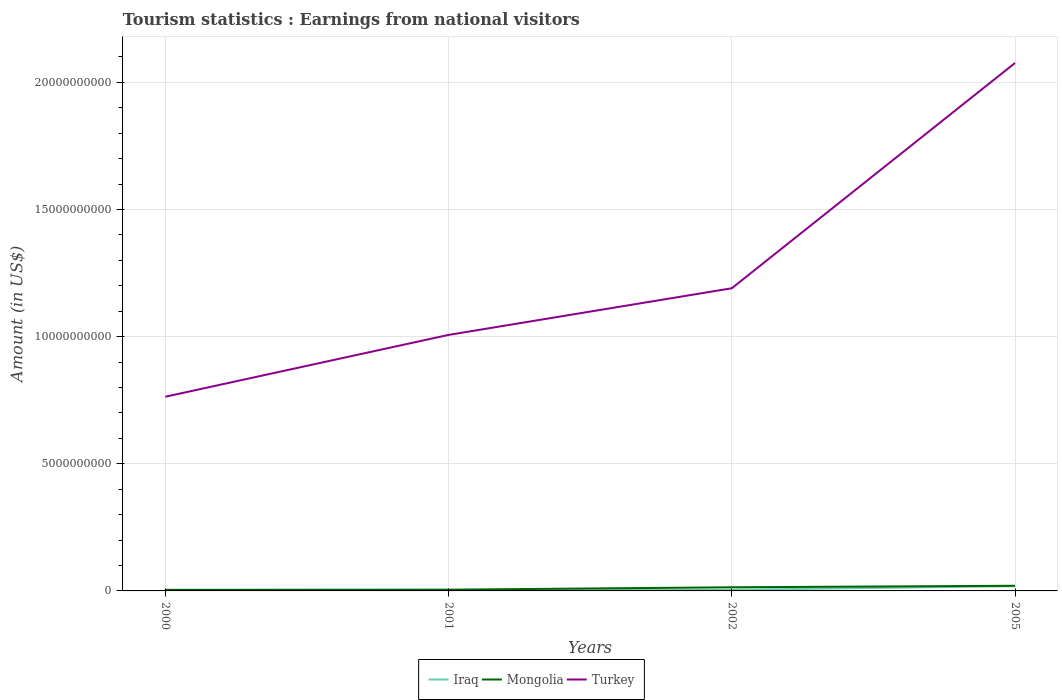Across all years, what is the maximum earnings from national visitors in Turkey?
Give a very brief answer. 7.64e+09. In which year was the earnings from national visitors in Iraq maximum?
Give a very brief answer. 2000. What is the total earnings from national visitors in Iraq in the graph?
Provide a succinct answer. -3.00e+07. What is the difference between the highest and the second highest earnings from national visitors in Turkey?
Provide a succinct answer. 1.31e+1. Are the values on the major ticks of Y-axis written in scientific E-notation?
Offer a terse response. No. Does the graph contain any zero values?
Give a very brief answer. No. Does the graph contain grids?
Ensure brevity in your answer.  Yes. Where does the legend appear in the graph?
Provide a succinct answer. Bottom center. How many legend labels are there?
Offer a terse response. 3. How are the legend labels stacked?
Offer a terse response. Horizontal. What is the title of the graph?
Offer a very short reply. Tourism statistics : Earnings from national visitors. Does "Bermuda" appear as one of the legend labels in the graph?
Make the answer very short. No. What is the label or title of the Y-axis?
Ensure brevity in your answer.  Amount (in US$). What is the Amount (in US$) of Iraq in 2000?
Your response must be concise. 2.00e+06. What is the Amount (in US$) of Mongolia in 2000?
Offer a terse response. 4.30e+07. What is the Amount (in US$) in Turkey in 2000?
Offer a very short reply. 7.64e+09. What is the Amount (in US$) of Iraq in 2001?
Provide a short and direct response. 1.50e+07. What is the Amount (in US$) in Mongolia in 2001?
Ensure brevity in your answer.  4.90e+07. What is the Amount (in US$) of Turkey in 2001?
Ensure brevity in your answer.  1.01e+1. What is the Amount (in US$) of Iraq in 2002?
Offer a terse response. 4.50e+07. What is the Amount (in US$) in Mongolia in 2002?
Your response must be concise. 1.43e+08. What is the Amount (in US$) of Turkey in 2002?
Provide a short and direct response. 1.19e+1. What is the Amount (in US$) in Iraq in 2005?
Give a very brief answer. 1.86e+08. What is the Amount (in US$) of Mongolia in 2005?
Your response must be concise. 2.03e+08. What is the Amount (in US$) of Turkey in 2005?
Offer a very short reply. 2.08e+1. Across all years, what is the maximum Amount (in US$) of Iraq?
Offer a very short reply. 1.86e+08. Across all years, what is the maximum Amount (in US$) of Mongolia?
Your answer should be very brief. 2.03e+08. Across all years, what is the maximum Amount (in US$) in Turkey?
Ensure brevity in your answer.  2.08e+1. Across all years, what is the minimum Amount (in US$) of Mongolia?
Give a very brief answer. 4.30e+07. Across all years, what is the minimum Amount (in US$) in Turkey?
Your response must be concise. 7.64e+09. What is the total Amount (in US$) in Iraq in the graph?
Your answer should be compact. 2.48e+08. What is the total Amount (in US$) in Mongolia in the graph?
Make the answer very short. 4.38e+08. What is the total Amount (in US$) in Turkey in the graph?
Provide a short and direct response. 5.04e+1. What is the difference between the Amount (in US$) in Iraq in 2000 and that in 2001?
Make the answer very short. -1.30e+07. What is the difference between the Amount (in US$) of Mongolia in 2000 and that in 2001?
Your answer should be compact. -6.00e+06. What is the difference between the Amount (in US$) of Turkey in 2000 and that in 2001?
Keep it short and to the point. -2.43e+09. What is the difference between the Amount (in US$) of Iraq in 2000 and that in 2002?
Provide a succinct answer. -4.30e+07. What is the difference between the Amount (in US$) in Mongolia in 2000 and that in 2002?
Give a very brief answer. -1.00e+08. What is the difference between the Amount (in US$) of Turkey in 2000 and that in 2002?
Your answer should be very brief. -4.26e+09. What is the difference between the Amount (in US$) in Iraq in 2000 and that in 2005?
Offer a very short reply. -1.84e+08. What is the difference between the Amount (in US$) in Mongolia in 2000 and that in 2005?
Ensure brevity in your answer.  -1.60e+08. What is the difference between the Amount (in US$) of Turkey in 2000 and that in 2005?
Provide a short and direct response. -1.31e+1. What is the difference between the Amount (in US$) in Iraq in 2001 and that in 2002?
Provide a succinct answer. -3.00e+07. What is the difference between the Amount (in US$) of Mongolia in 2001 and that in 2002?
Offer a very short reply. -9.40e+07. What is the difference between the Amount (in US$) of Turkey in 2001 and that in 2002?
Provide a succinct answer. -1.83e+09. What is the difference between the Amount (in US$) of Iraq in 2001 and that in 2005?
Your answer should be very brief. -1.71e+08. What is the difference between the Amount (in US$) of Mongolia in 2001 and that in 2005?
Provide a succinct answer. -1.54e+08. What is the difference between the Amount (in US$) of Turkey in 2001 and that in 2005?
Ensure brevity in your answer.  -1.07e+1. What is the difference between the Amount (in US$) in Iraq in 2002 and that in 2005?
Your response must be concise. -1.41e+08. What is the difference between the Amount (in US$) in Mongolia in 2002 and that in 2005?
Keep it short and to the point. -6.00e+07. What is the difference between the Amount (in US$) of Turkey in 2002 and that in 2005?
Provide a succinct answer. -8.86e+09. What is the difference between the Amount (in US$) of Iraq in 2000 and the Amount (in US$) of Mongolia in 2001?
Keep it short and to the point. -4.70e+07. What is the difference between the Amount (in US$) of Iraq in 2000 and the Amount (in US$) of Turkey in 2001?
Your answer should be compact. -1.01e+1. What is the difference between the Amount (in US$) in Mongolia in 2000 and the Amount (in US$) in Turkey in 2001?
Your answer should be compact. -1.00e+1. What is the difference between the Amount (in US$) in Iraq in 2000 and the Amount (in US$) in Mongolia in 2002?
Keep it short and to the point. -1.41e+08. What is the difference between the Amount (in US$) of Iraq in 2000 and the Amount (in US$) of Turkey in 2002?
Make the answer very short. -1.19e+1. What is the difference between the Amount (in US$) in Mongolia in 2000 and the Amount (in US$) in Turkey in 2002?
Give a very brief answer. -1.19e+1. What is the difference between the Amount (in US$) in Iraq in 2000 and the Amount (in US$) in Mongolia in 2005?
Offer a terse response. -2.01e+08. What is the difference between the Amount (in US$) in Iraq in 2000 and the Amount (in US$) in Turkey in 2005?
Provide a succinct answer. -2.08e+1. What is the difference between the Amount (in US$) of Mongolia in 2000 and the Amount (in US$) of Turkey in 2005?
Your answer should be compact. -2.07e+1. What is the difference between the Amount (in US$) of Iraq in 2001 and the Amount (in US$) of Mongolia in 2002?
Your response must be concise. -1.28e+08. What is the difference between the Amount (in US$) of Iraq in 2001 and the Amount (in US$) of Turkey in 2002?
Make the answer very short. -1.19e+1. What is the difference between the Amount (in US$) in Mongolia in 2001 and the Amount (in US$) in Turkey in 2002?
Provide a short and direct response. -1.19e+1. What is the difference between the Amount (in US$) in Iraq in 2001 and the Amount (in US$) in Mongolia in 2005?
Offer a terse response. -1.88e+08. What is the difference between the Amount (in US$) of Iraq in 2001 and the Amount (in US$) of Turkey in 2005?
Offer a terse response. -2.07e+1. What is the difference between the Amount (in US$) in Mongolia in 2001 and the Amount (in US$) in Turkey in 2005?
Your response must be concise. -2.07e+1. What is the difference between the Amount (in US$) of Iraq in 2002 and the Amount (in US$) of Mongolia in 2005?
Make the answer very short. -1.58e+08. What is the difference between the Amount (in US$) in Iraq in 2002 and the Amount (in US$) in Turkey in 2005?
Offer a very short reply. -2.07e+1. What is the difference between the Amount (in US$) of Mongolia in 2002 and the Amount (in US$) of Turkey in 2005?
Provide a succinct answer. -2.06e+1. What is the average Amount (in US$) of Iraq per year?
Your answer should be very brief. 6.20e+07. What is the average Amount (in US$) of Mongolia per year?
Offer a very short reply. 1.10e+08. What is the average Amount (in US$) of Turkey per year?
Your answer should be very brief. 1.26e+1. In the year 2000, what is the difference between the Amount (in US$) in Iraq and Amount (in US$) in Mongolia?
Your answer should be compact. -4.10e+07. In the year 2000, what is the difference between the Amount (in US$) in Iraq and Amount (in US$) in Turkey?
Offer a very short reply. -7.63e+09. In the year 2000, what is the difference between the Amount (in US$) of Mongolia and Amount (in US$) of Turkey?
Provide a succinct answer. -7.59e+09. In the year 2001, what is the difference between the Amount (in US$) of Iraq and Amount (in US$) of Mongolia?
Offer a very short reply. -3.40e+07. In the year 2001, what is the difference between the Amount (in US$) in Iraq and Amount (in US$) in Turkey?
Provide a succinct answer. -1.01e+1. In the year 2001, what is the difference between the Amount (in US$) in Mongolia and Amount (in US$) in Turkey?
Provide a succinct answer. -1.00e+1. In the year 2002, what is the difference between the Amount (in US$) of Iraq and Amount (in US$) of Mongolia?
Provide a succinct answer. -9.80e+07. In the year 2002, what is the difference between the Amount (in US$) of Iraq and Amount (in US$) of Turkey?
Your answer should be very brief. -1.19e+1. In the year 2002, what is the difference between the Amount (in US$) in Mongolia and Amount (in US$) in Turkey?
Your answer should be compact. -1.18e+1. In the year 2005, what is the difference between the Amount (in US$) in Iraq and Amount (in US$) in Mongolia?
Your response must be concise. -1.70e+07. In the year 2005, what is the difference between the Amount (in US$) of Iraq and Amount (in US$) of Turkey?
Your answer should be very brief. -2.06e+1. In the year 2005, what is the difference between the Amount (in US$) of Mongolia and Amount (in US$) of Turkey?
Your answer should be very brief. -2.06e+1. What is the ratio of the Amount (in US$) of Iraq in 2000 to that in 2001?
Ensure brevity in your answer.  0.13. What is the ratio of the Amount (in US$) of Mongolia in 2000 to that in 2001?
Your answer should be very brief. 0.88. What is the ratio of the Amount (in US$) of Turkey in 2000 to that in 2001?
Your answer should be compact. 0.76. What is the ratio of the Amount (in US$) in Iraq in 2000 to that in 2002?
Ensure brevity in your answer.  0.04. What is the ratio of the Amount (in US$) of Mongolia in 2000 to that in 2002?
Your answer should be very brief. 0.3. What is the ratio of the Amount (in US$) in Turkey in 2000 to that in 2002?
Give a very brief answer. 0.64. What is the ratio of the Amount (in US$) in Iraq in 2000 to that in 2005?
Give a very brief answer. 0.01. What is the ratio of the Amount (in US$) in Mongolia in 2000 to that in 2005?
Offer a very short reply. 0.21. What is the ratio of the Amount (in US$) in Turkey in 2000 to that in 2005?
Provide a succinct answer. 0.37. What is the ratio of the Amount (in US$) of Iraq in 2001 to that in 2002?
Your answer should be compact. 0.33. What is the ratio of the Amount (in US$) in Mongolia in 2001 to that in 2002?
Make the answer very short. 0.34. What is the ratio of the Amount (in US$) in Turkey in 2001 to that in 2002?
Offer a very short reply. 0.85. What is the ratio of the Amount (in US$) in Iraq in 2001 to that in 2005?
Provide a short and direct response. 0.08. What is the ratio of the Amount (in US$) in Mongolia in 2001 to that in 2005?
Give a very brief answer. 0.24. What is the ratio of the Amount (in US$) of Turkey in 2001 to that in 2005?
Ensure brevity in your answer.  0.48. What is the ratio of the Amount (in US$) in Iraq in 2002 to that in 2005?
Offer a very short reply. 0.24. What is the ratio of the Amount (in US$) of Mongolia in 2002 to that in 2005?
Make the answer very short. 0.7. What is the ratio of the Amount (in US$) of Turkey in 2002 to that in 2005?
Offer a terse response. 0.57. What is the difference between the highest and the second highest Amount (in US$) in Iraq?
Your answer should be very brief. 1.41e+08. What is the difference between the highest and the second highest Amount (in US$) of Mongolia?
Your response must be concise. 6.00e+07. What is the difference between the highest and the second highest Amount (in US$) in Turkey?
Keep it short and to the point. 8.86e+09. What is the difference between the highest and the lowest Amount (in US$) in Iraq?
Make the answer very short. 1.84e+08. What is the difference between the highest and the lowest Amount (in US$) in Mongolia?
Provide a succinct answer. 1.60e+08. What is the difference between the highest and the lowest Amount (in US$) of Turkey?
Your answer should be very brief. 1.31e+1. 